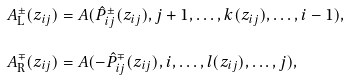Convert formula to latex. <formula><loc_0><loc_0><loc_500><loc_500>A ^ { \pm } _ { \text {L} } ( z _ { i j } ) & = A ( \hat { P } _ { i j } ^ { \pm } ( z _ { i j } ) , j + 1 , \dots , k ( z _ { i j } ) , \dots , i - 1 ) , \\ A ^ { \mp } _ { \text {R} } ( z _ { i j } ) & = A ( - \hat { P } _ { i j } ^ { \mp } ( z _ { i j } ) , i , \dots , l ( z _ { i j } ) , \dots , j ) ,</formula> 